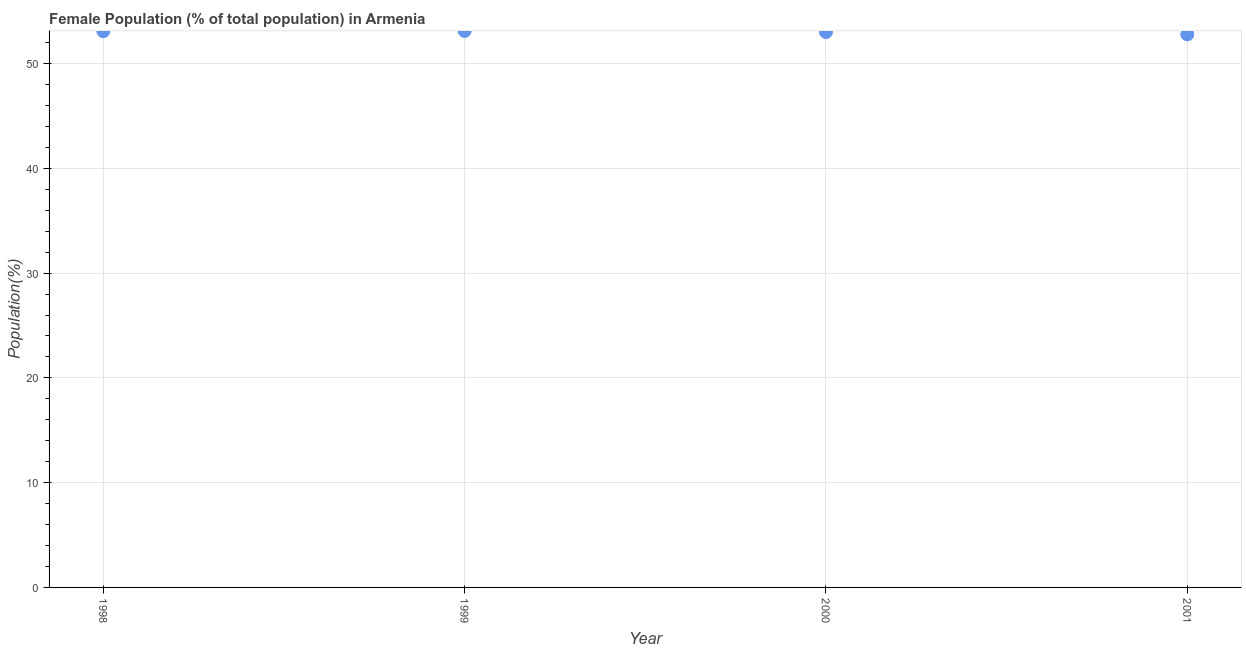What is the female population in 1998?
Make the answer very short. 53.09. Across all years, what is the maximum female population?
Offer a terse response. 53.11. Across all years, what is the minimum female population?
Offer a terse response. 52.79. In which year was the female population minimum?
Make the answer very short. 2001. What is the sum of the female population?
Offer a terse response. 212. What is the difference between the female population in 1998 and 2001?
Offer a very short reply. 0.3. What is the average female population per year?
Offer a very short reply. 53. What is the median female population?
Give a very brief answer. 53.05. In how many years, is the female population greater than 50 %?
Provide a short and direct response. 4. What is the ratio of the female population in 1998 to that in 2000?
Your response must be concise. 1. Is the difference between the female population in 1999 and 2000 greater than the difference between any two years?
Offer a very short reply. No. What is the difference between the highest and the second highest female population?
Offer a very short reply. 0.02. What is the difference between the highest and the lowest female population?
Make the answer very short. 0.32. In how many years, is the female population greater than the average female population taken over all years?
Keep it short and to the point. 3. How many years are there in the graph?
Give a very brief answer. 4. What is the difference between two consecutive major ticks on the Y-axis?
Provide a short and direct response. 10. Does the graph contain any zero values?
Offer a terse response. No. Does the graph contain grids?
Your answer should be compact. Yes. What is the title of the graph?
Offer a terse response. Female Population (% of total population) in Armenia. What is the label or title of the Y-axis?
Keep it short and to the point. Population(%). What is the Population(%) in 1998?
Ensure brevity in your answer.  53.09. What is the Population(%) in 1999?
Provide a succinct answer. 53.11. What is the Population(%) in 2000?
Provide a short and direct response. 53.01. What is the Population(%) in 2001?
Your answer should be very brief. 52.79. What is the difference between the Population(%) in 1998 and 1999?
Your response must be concise. -0.02. What is the difference between the Population(%) in 1998 and 2000?
Ensure brevity in your answer.  0.08. What is the difference between the Population(%) in 1998 and 2001?
Your answer should be compact. 0.3. What is the difference between the Population(%) in 1999 and 2000?
Offer a very short reply. 0.1. What is the difference between the Population(%) in 1999 and 2001?
Give a very brief answer. 0.32. What is the difference between the Population(%) in 2000 and 2001?
Offer a terse response. 0.22. What is the ratio of the Population(%) in 1998 to that in 1999?
Provide a short and direct response. 1. What is the ratio of the Population(%) in 1998 to that in 2000?
Your answer should be very brief. 1. What is the ratio of the Population(%) in 2000 to that in 2001?
Ensure brevity in your answer.  1. 